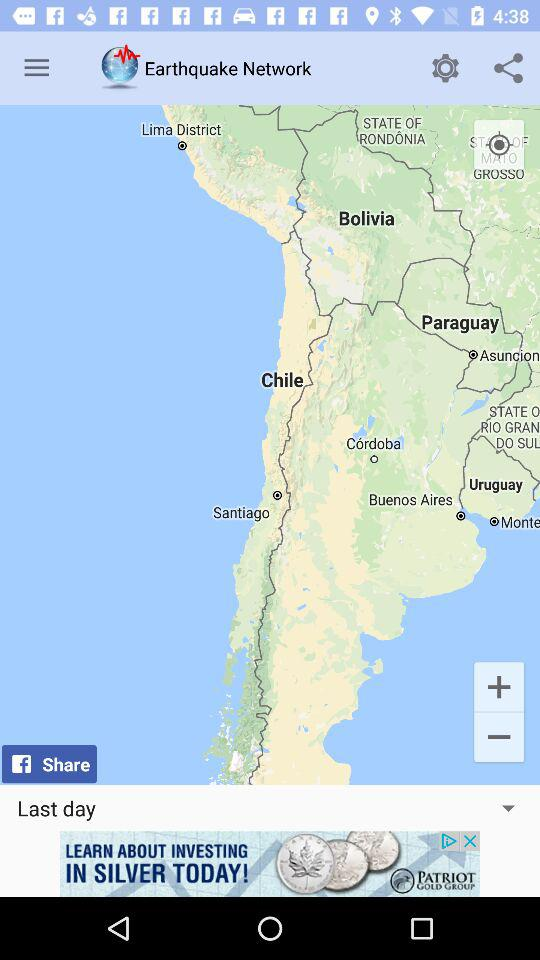What day's data is shown? The data is shown for the last day. 